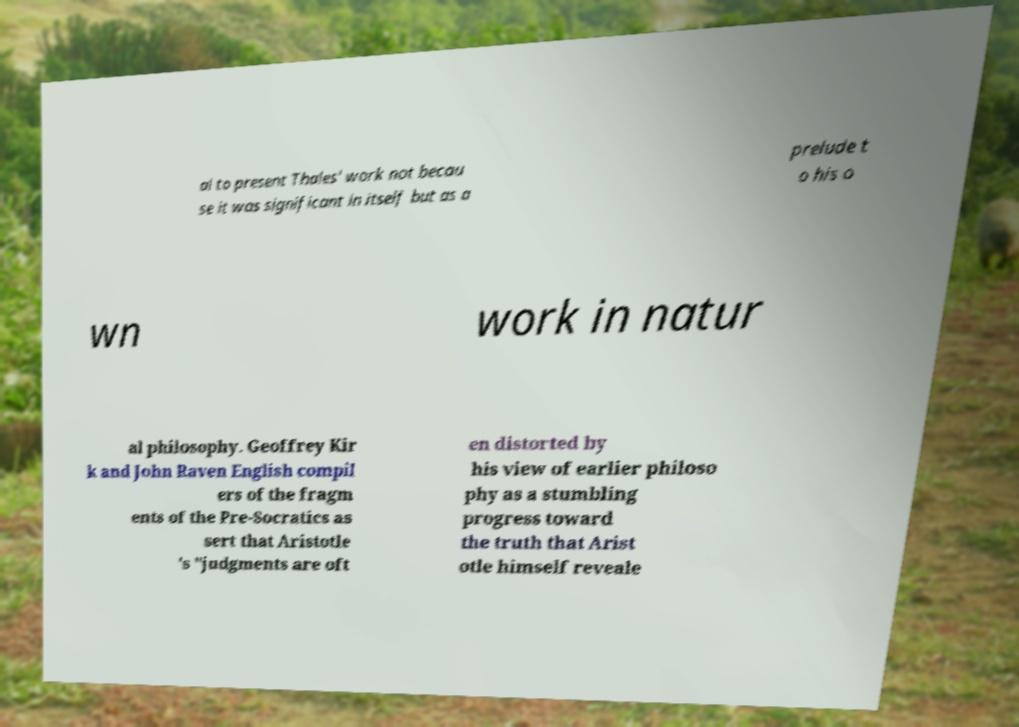What messages or text are displayed in this image? I need them in a readable, typed format. al to present Thales' work not becau se it was significant in itself but as a prelude t o his o wn work in natur al philosophy. Geoffrey Kir k and John Raven English compil ers of the fragm ents of the Pre-Socratics as sert that Aristotle 's "judgments are oft en distorted by his view of earlier philoso phy as a stumbling progress toward the truth that Arist otle himself reveale 